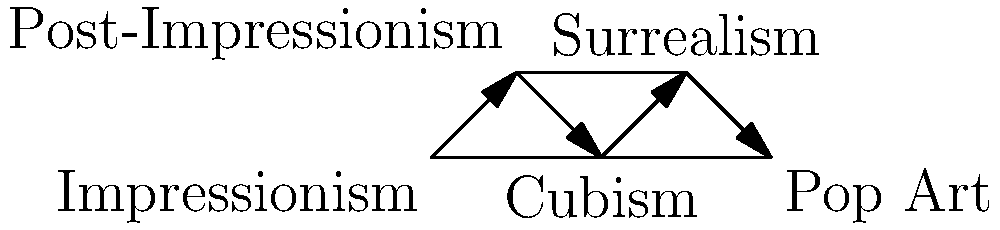In the graph depicting the influence of art movements on each other and contemporary culture, which movement appears to have the most direct connections, suggesting it played a pivotal role in shaping subsequent artistic styles and cultural trends? To answer this question, we need to analyze the graph and count the number of connections (edges) for each art movement:

1. Impressionism: 2 connections (to Post-Impressionism and Cubism)
2. Post-Impressionism: 3 connections (to Impressionism, Cubism, and Surrealism)
3. Cubism: 4 connections (to Impressionism, Post-Impressionism, Surrealism, and Pop Art)
4. Surrealism: 3 connections (to Post-Impressionism, Cubism, and Pop Art)
5. Pop Art: 2 connections (to Cubism and Surrealism)

Cubism has the highest number of connections (4), indicating that it has direct links to the most other movements in this graph. This suggests that Cubism played a central role in influencing and being influenced by other major art movements of the 20th century.

The arrows in the graph also show a chronological flow of influence, with Cubism positioned in the middle of this progression. This further emphasizes its pivotal role in bridging earlier movements like Impressionism and Post-Impressionism with later movements like Surrealism and Pop Art.

Given Cubism's position and connections in this graph, it appears to have been a crucial turning point in the evolution of modern art, absorbing influences from earlier movements and significantly shaping the development of subsequent artistic styles.
Answer: Cubism 